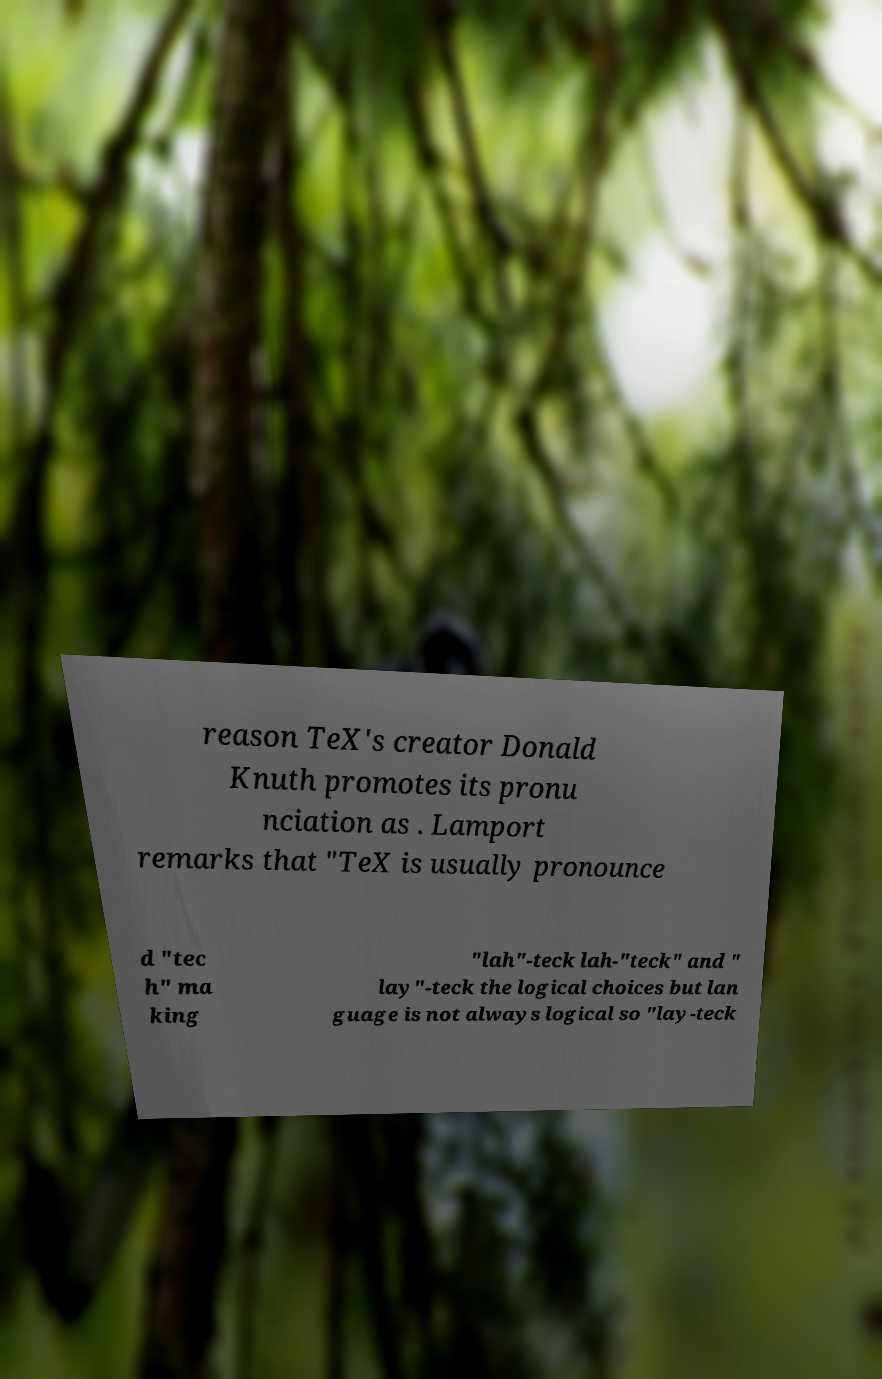Can you accurately transcribe the text from the provided image for me? reason TeX's creator Donald Knuth promotes its pronu nciation as . Lamport remarks that "TeX is usually pronounce d "tec h" ma king "lah"-teck lah-"teck" and " lay"-teck the logical choices but lan guage is not always logical so "lay-teck 